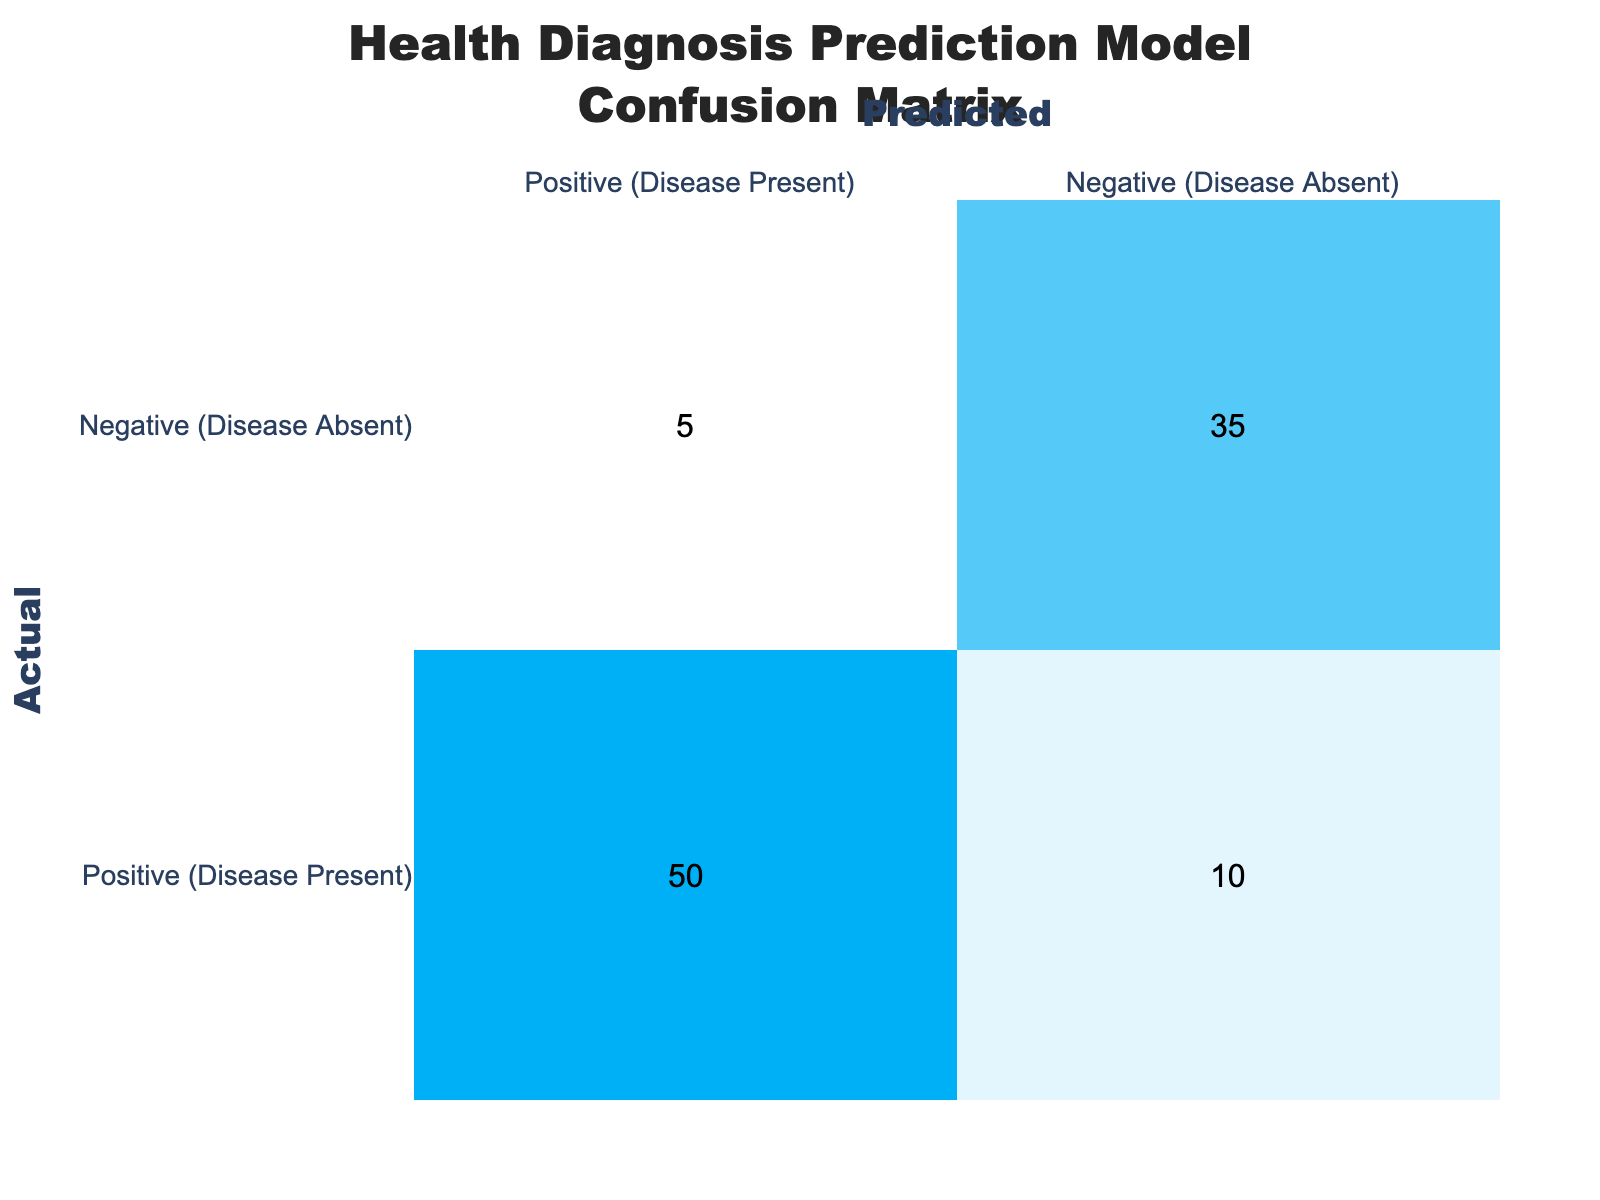What is the number of True Positives (TP) in the matrix? The True Positives (TP) refer to the condition where the model correctly predicts the presence of the disease. In the table, this value is found in the cell corresponding to the actual positive cases with predicted positive, which is 50.
Answer: 50 What is the number of False Negatives (FN) in the matrix? The False Negatives (FN) indicate the number of actual positive cases that were incorrectly predicted as negative. This value is located in the cell that represents actual positive cases with predicted negative, which is 10.
Answer: 10 How many instances were predicted as Positive by the model? To find the number of instances predicted as Positive, we need to sum the values in the column labeled Positive (Disease Present): 50 (True Positives) + 5 (False Positives) = 55.
Answer: 55 What is the total number of actual Negative cases? The total number of actual Negative cases can be calculated by summing the values in the Negative (Disease Absent) row: 5 (False Positives) + 35 (True Negatives) = 40.
Answer: 40 Is the model more accurate in predicting actual Positive cases than Negative cases? To determine model accuracy for actual Positive and Negative cases, we consider the rates: TP (50) relative to all actual Positives (60) gives us an accuracy of 83.3%, while TN (35) relative to all actual Negatives (40) gives us 87.5%. The model is more accurate for actual Negative cases since 87.5% is higher than 83.3%.
Answer: Yes What is the overall accuracy of the model? Overall accuracy can be calculated by taking the sum of True Positives and True Negatives and dividing by the total number of cases: (50 + 35) / (50 + 10 + 5 + 35) = 85 / 100 = 0.85 or 85%.
Answer: 85% What is the rate of False Positives in the model? The rate of False Positives is calculated by dividing the number of False Positives (5) by the total number of actual Negatives (40): 5 / (5 + 35) = 5 / 40 = 0.125 or 12.5%.
Answer: 12.5% What is the total number of cases the model classified as Negative? The number of cases classified as Negative can be determined by summing the values in the Negative (Disease Absent) column: 10 (False Negatives) + 35 (True Negatives) = 45.
Answer: 45 If the model predicted a case as Positive, what is the chance that it is actually Positive? The positive predictive value can be calculated by dividing True Positives (50) by the total predicted Positives (55). This gives us 50 / 55 ≈ 0.909 or 90.9%.
Answer: 90.9% 